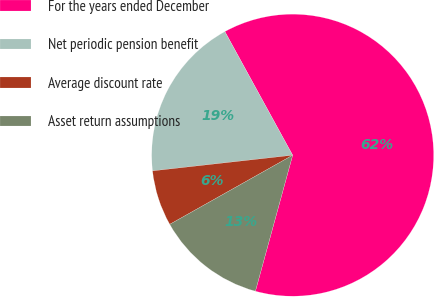Convert chart to OTSL. <chart><loc_0><loc_0><loc_500><loc_500><pie_chart><fcel>For the years ended December<fcel>Net periodic pension benefit<fcel>Average discount rate<fcel>Asset return assumptions<nl><fcel>62.23%<fcel>18.79%<fcel>6.38%<fcel>12.59%<nl></chart> 